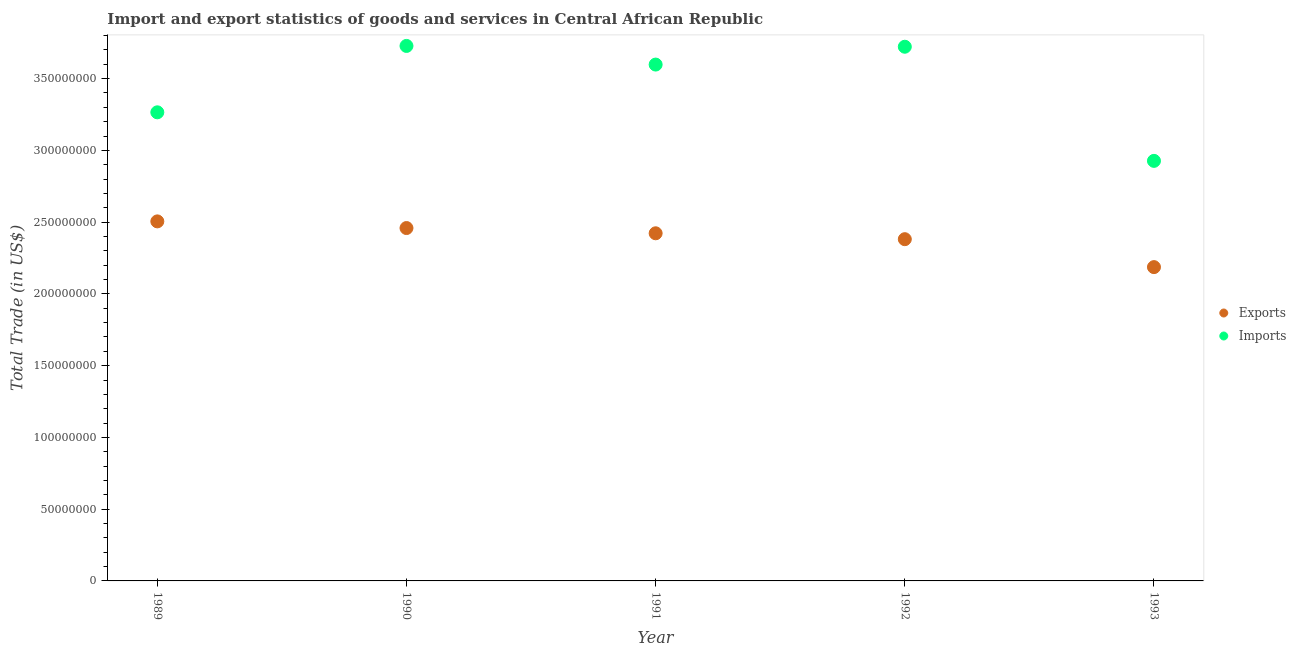How many different coloured dotlines are there?
Your response must be concise. 2. Is the number of dotlines equal to the number of legend labels?
Your answer should be very brief. Yes. What is the imports of goods and services in 1989?
Offer a very short reply. 3.27e+08. Across all years, what is the maximum imports of goods and services?
Provide a short and direct response. 3.73e+08. Across all years, what is the minimum imports of goods and services?
Keep it short and to the point. 2.93e+08. What is the total export of goods and services in the graph?
Your answer should be very brief. 1.20e+09. What is the difference between the export of goods and services in 1989 and that in 1992?
Keep it short and to the point. 1.24e+07. What is the difference between the imports of goods and services in 1992 and the export of goods and services in 1991?
Your answer should be very brief. 1.30e+08. What is the average export of goods and services per year?
Your answer should be very brief. 2.39e+08. In the year 1989, what is the difference between the export of goods and services and imports of goods and services?
Give a very brief answer. -7.60e+07. In how many years, is the imports of goods and services greater than 230000000 US$?
Make the answer very short. 5. What is the ratio of the imports of goods and services in 1991 to that in 1992?
Give a very brief answer. 0.97. What is the difference between the highest and the second highest export of goods and services?
Ensure brevity in your answer.  4.64e+06. What is the difference between the highest and the lowest imports of goods and services?
Ensure brevity in your answer.  8.01e+07. In how many years, is the export of goods and services greater than the average export of goods and services taken over all years?
Your answer should be very brief. 3. Does the export of goods and services monotonically increase over the years?
Offer a very short reply. No. Is the export of goods and services strictly greater than the imports of goods and services over the years?
Your answer should be compact. No. How many years are there in the graph?
Ensure brevity in your answer.  5. Are the values on the major ticks of Y-axis written in scientific E-notation?
Offer a very short reply. No. Where does the legend appear in the graph?
Ensure brevity in your answer.  Center right. What is the title of the graph?
Your response must be concise. Import and export statistics of goods and services in Central African Republic. What is the label or title of the Y-axis?
Provide a succinct answer. Total Trade (in US$). What is the Total Trade (in US$) in Exports in 1989?
Keep it short and to the point. 2.51e+08. What is the Total Trade (in US$) in Imports in 1989?
Your answer should be compact. 3.27e+08. What is the Total Trade (in US$) in Exports in 1990?
Ensure brevity in your answer.  2.46e+08. What is the Total Trade (in US$) in Imports in 1990?
Offer a very short reply. 3.73e+08. What is the Total Trade (in US$) in Exports in 1991?
Offer a very short reply. 2.42e+08. What is the Total Trade (in US$) in Imports in 1991?
Keep it short and to the point. 3.60e+08. What is the Total Trade (in US$) of Exports in 1992?
Keep it short and to the point. 2.38e+08. What is the Total Trade (in US$) in Imports in 1992?
Your answer should be very brief. 3.72e+08. What is the Total Trade (in US$) of Exports in 1993?
Your answer should be very brief. 2.19e+08. What is the Total Trade (in US$) of Imports in 1993?
Keep it short and to the point. 2.93e+08. Across all years, what is the maximum Total Trade (in US$) in Exports?
Your answer should be compact. 2.51e+08. Across all years, what is the maximum Total Trade (in US$) of Imports?
Your answer should be very brief. 3.73e+08. Across all years, what is the minimum Total Trade (in US$) in Exports?
Offer a very short reply. 2.19e+08. Across all years, what is the minimum Total Trade (in US$) in Imports?
Give a very brief answer. 2.93e+08. What is the total Total Trade (in US$) in Exports in the graph?
Provide a succinct answer. 1.20e+09. What is the total Total Trade (in US$) in Imports in the graph?
Your response must be concise. 1.72e+09. What is the difference between the Total Trade (in US$) of Exports in 1989 and that in 1990?
Make the answer very short. 4.64e+06. What is the difference between the Total Trade (in US$) in Imports in 1989 and that in 1990?
Your answer should be very brief. -4.63e+07. What is the difference between the Total Trade (in US$) of Exports in 1989 and that in 1991?
Make the answer very short. 8.30e+06. What is the difference between the Total Trade (in US$) of Imports in 1989 and that in 1991?
Offer a terse response. -3.33e+07. What is the difference between the Total Trade (in US$) of Exports in 1989 and that in 1992?
Provide a short and direct response. 1.24e+07. What is the difference between the Total Trade (in US$) of Imports in 1989 and that in 1992?
Provide a short and direct response. -4.57e+07. What is the difference between the Total Trade (in US$) of Exports in 1989 and that in 1993?
Offer a very short reply. 3.19e+07. What is the difference between the Total Trade (in US$) of Imports in 1989 and that in 1993?
Your response must be concise. 3.38e+07. What is the difference between the Total Trade (in US$) in Exports in 1990 and that in 1991?
Keep it short and to the point. 3.66e+06. What is the difference between the Total Trade (in US$) in Imports in 1990 and that in 1991?
Your answer should be compact. 1.30e+07. What is the difference between the Total Trade (in US$) of Exports in 1990 and that in 1992?
Your answer should be compact. 7.76e+06. What is the difference between the Total Trade (in US$) in Imports in 1990 and that in 1992?
Your response must be concise. 5.62e+05. What is the difference between the Total Trade (in US$) in Exports in 1990 and that in 1993?
Ensure brevity in your answer.  2.72e+07. What is the difference between the Total Trade (in US$) in Imports in 1990 and that in 1993?
Offer a terse response. 8.01e+07. What is the difference between the Total Trade (in US$) of Exports in 1991 and that in 1992?
Ensure brevity in your answer.  4.10e+06. What is the difference between the Total Trade (in US$) of Imports in 1991 and that in 1992?
Offer a very short reply. -1.24e+07. What is the difference between the Total Trade (in US$) in Exports in 1991 and that in 1993?
Your answer should be compact. 2.36e+07. What is the difference between the Total Trade (in US$) of Imports in 1991 and that in 1993?
Ensure brevity in your answer.  6.71e+07. What is the difference between the Total Trade (in US$) in Exports in 1992 and that in 1993?
Offer a terse response. 1.95e+07. What is the difference between the Total Trade (in US$) in Imports in 1992 and that in 1993?
Ensure brevity in your answer.  7.95e+07. What is the difference between the Total Trade (in US$) in Exports in 1989 and the Total Trade (in US$) in Imports in 1990?
Your answer should be very brief. -1.22e+08. What is the difference between the Total Trade (in US$) in Exports in 1989 and the Total Trade (in US$) in Imports in 1991?
Offer a very short reply. -1.09e+08. What is the difference between the Total Trade (in US$) of Exports in 1989 and the Total Trade (in US$) of Imports in 1992?
Keep it short and to the point. -1.22e+08. What is the difference between the Total Trade (in US$) in Exports in 1989 and the Total Trade (in US$) in Imports in 1993?
Your answer should be very brief. -4.22e+07. What is the difference between the Total Trade (in US$) in Exports in 1990 and the Total Trade (in US$) in Imports in 1991?
Keep it short and to the point. -1.14e+08. What is the difference between the Total Trade (in US$) in Exports in 1990 and the Total Trade (in US$) in Imports in 1992?
Give a very brief answer. -1.26e+08. What is the difference between the Total Trade (in US$) in Exports in 1990 and the Total Trade (in US$) in Imports in 1993?
Make the answer very short. -4.68e+07. What is the difference between the Total Trade (in US$) of Exports in 1991 and the Total Trade (in US$) of Imports in 1992?
Your answer should be compact. -1.30e+08. What is the difference between the Total Trade (in US$) in Exports in 1991 and the Total Trade (in US$) in Imports in 1993?
Your answer should be very brief. -5.05e+07. What is the difference between the Total Trade (in US$) in Exports in 1992 and the Total Trade (in US$) in Imports in 1993?
Offer a terse response. -5.46e+07. What is the average Total Trade (in US$) in Exports per year?
Your answer should be compact. 2.39e+08. What is the average Total Trade (in US$) in Imports per year?
Offer a very short reply. 3.45e+08. In the year 1989, what is the difference between the Total Trade (in US$) of Exports and Total Trade (in US$) of Imports?
Give a very brief answer. -7.60e+07. In the year 1990, what is the difference between the Total Trade (in US$) in Exports and Total Trade (in US$) in Imports?
Provide a succinct answer. -1.27e+08. In the year 1991, what is the difference between the Total Trade (in US$) in Exports and Total Trade (in US$) in Imports?
Keep it short and to the point. -1.18e+08. In the year 1992, what is the difference between the Total Trade (in US$) of Exports and Total Trade (in US$) of Imports?
Keep it short and to the point. -1.34e+08. In the year 1993, what is the difference between the Total Trade (in US$) of Exports and Total Trade (in US$) of Imports?
Your response must be concise. -7.40e+07. What is the ratio of the Total Trade (in US$) of Exports in 1989 to that in 1990?
Your answer should be very brief. 1.02. What is the ratio of the Total Trade (in US$) in Imports in 1989 to that in 1990?
Offer a very short reply. 0.88. What is the ratio of the Total Trade (in US$) in Exports in 1989 to that in 1991?
Your answer should be compact. 1.03. What is the ratio of the Total Trade (in US$) of Imports in 1989 to that in 1991?
Your answer should be compact. 0.91. What is the ratio of the Total Trade (in US$) of Exports in 1989 to that in 1992?
Your response must be concise. 1.05. What is the ratio of the Total Trade (in US$) of Imports in 1989 to that in 1992?
Provide a succinct answer. 0.88. What is the ratio of the Total Trade (in US$) in Exports in 1989 to that in 1993?
Give a very brief answer. 1.15. What is the ratio of the Total Trade (in US$) of Imports in 1989 to that in 1993?
Provide a short and direct response. 1.12. What is the ratio of the Total Trade (in US$) in Exports in 1990 to that in 1991?
Provide a succinct answer. 1.02. What is the ratio of the Total Trade (in US$) of Imports in 1990 to that in 1991?
Give a very brief answer. 1.04. What is the ratio of the Total Trade (in US$) of Exports in 1990 to that in 1992?
Offer a very short reply. 1.03. What is the ratio of the Total Trade (in US$) of Imports in 1990 to that in 1992?
Provide a succinct answer. 1. What is the ratio of the Total Trade (in US$) in Exports in 1990 to that in 1993?
Offer a terse response. 1.12. What is the ratio of the Total Trade (in US$) in Imports in 1990 to that in 1993?
Provide a short and direct response. 1.27. What is the ratio of the Total Trade (in US$) of Exports in 1991 to that in 1992?
Offer a terse response. 1.02. What is the ratio of the Total Trade (in US$) of Imports in 1991 to that in 1992?
Offer a terse response. 0.97. What is the ratio of the Total Trade (in US$) of Exports in 1991 to that in 1993?
Offer a terse response. 1.11. What is the ratio of the Total Trade (in US$) of Imports in 1991 to that in 1993?
Provide a succinct answer. 1.23. What is the ratio of the Total Trade (in US$) of Exports in 1992 to that in 1993?
Ensure brevity in your answer.  1.09. What is the ratio of the Total Trade (in US$) of Imports in 1992 to that in 1993?
Your answer should be very brief. 1.27. What is the difference between the highest and the second highest Total Trade (in US$) in Exports?
Keep it short and to the point. 4.64e+06. What is the difference between the highest and the second highest Total Trade (in US$) of Imports?
Your answer should be very brief. 5.62e+05. What is the difference between the highest and the lowest Total Trade (in US$) in Exports?
Provide a short and direct response. 3.19e+07. What is the difference between the highest and the lowest Total Trade (in US$) in Imports?
Ensure brevity in your answer.  8.01e+07. 